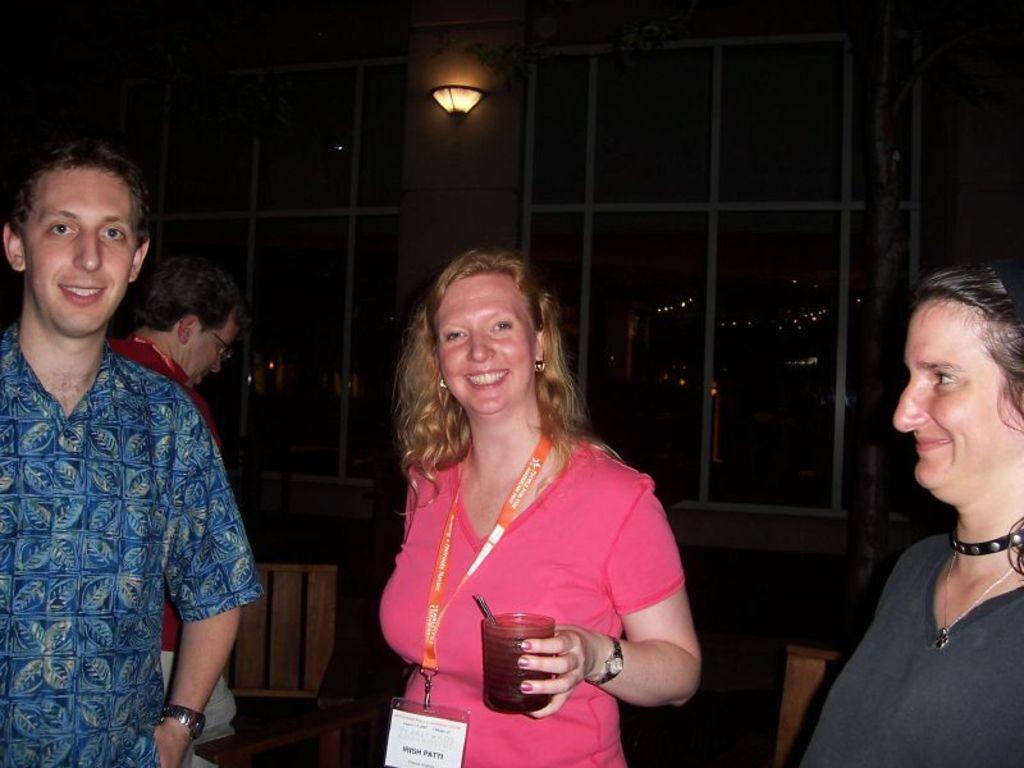What are the people in the image doing? The persons standing on the floor are likely engaged in some activity or standing in a particular setting. Can you describe the background of the image? In the background of the image, there are windows, light, chairs, and buildings. How many people can be seen in the image? There is at least one person in the background of the image, in addition to the persons standing on the floor. What type of mask is the person in the image wearing? There is no person wearing a mask in the image. How does the image depict the act of saying good-bye? The image does not depict the act of saying good-bye; it simply shows persons standing on the floor and the background elements. 